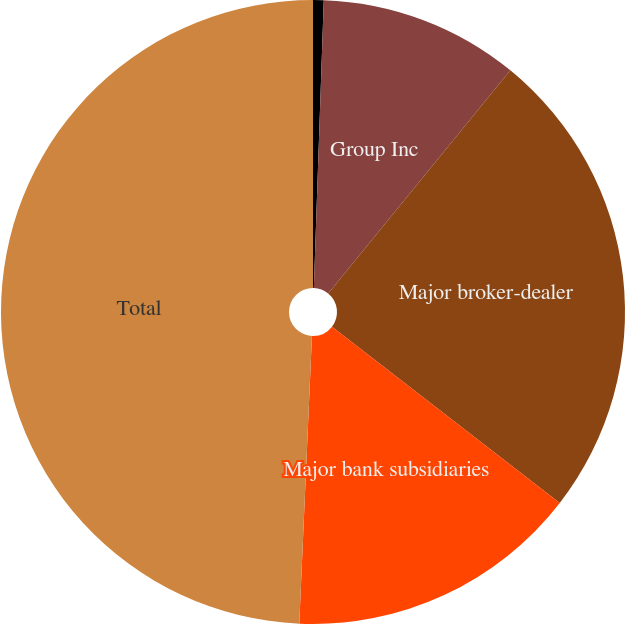<chart> <loc_0><loc_0><loc_500><loc_500><pie_chart><fcel>in millions<fcel>Group Inc<fcel>Major broker-dealer<fcel>Major bank subsidiaries<fcel>Total<nl><fcel>0.55%<fcel>10.35%<fcel>24.58%<fcel>15.22%<fcel>49.3%<nl></chart> 